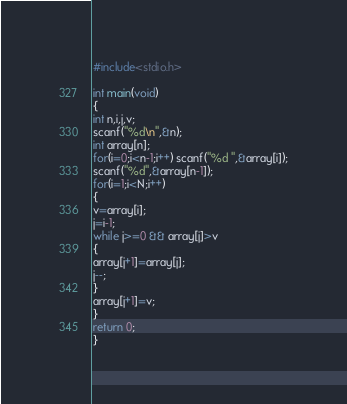<code> <loc_0><loc_0><loc_500><loc_500><_C_>#include<stdio.h>

int main(void)
{
int n,i,j,v;
scanf("%d\n",&n);
int array[n];
for(i=0;i<n-1;i++) scanf("%d ",&array[i]);
scanf("%d",&array[n-1]);
for(i=1;i<N;i++)
{
v=array[i];
j=i-1;
while j>=0 && array[j]>v
{
array[j+1]=array[j];
j--;
}
array[j+1]=v;
}
return 0;
}</code> 